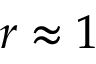Convert formula to latex. <formula><loc_0><loc_0><loc_500><loc_500>r \approx 1</formula> 